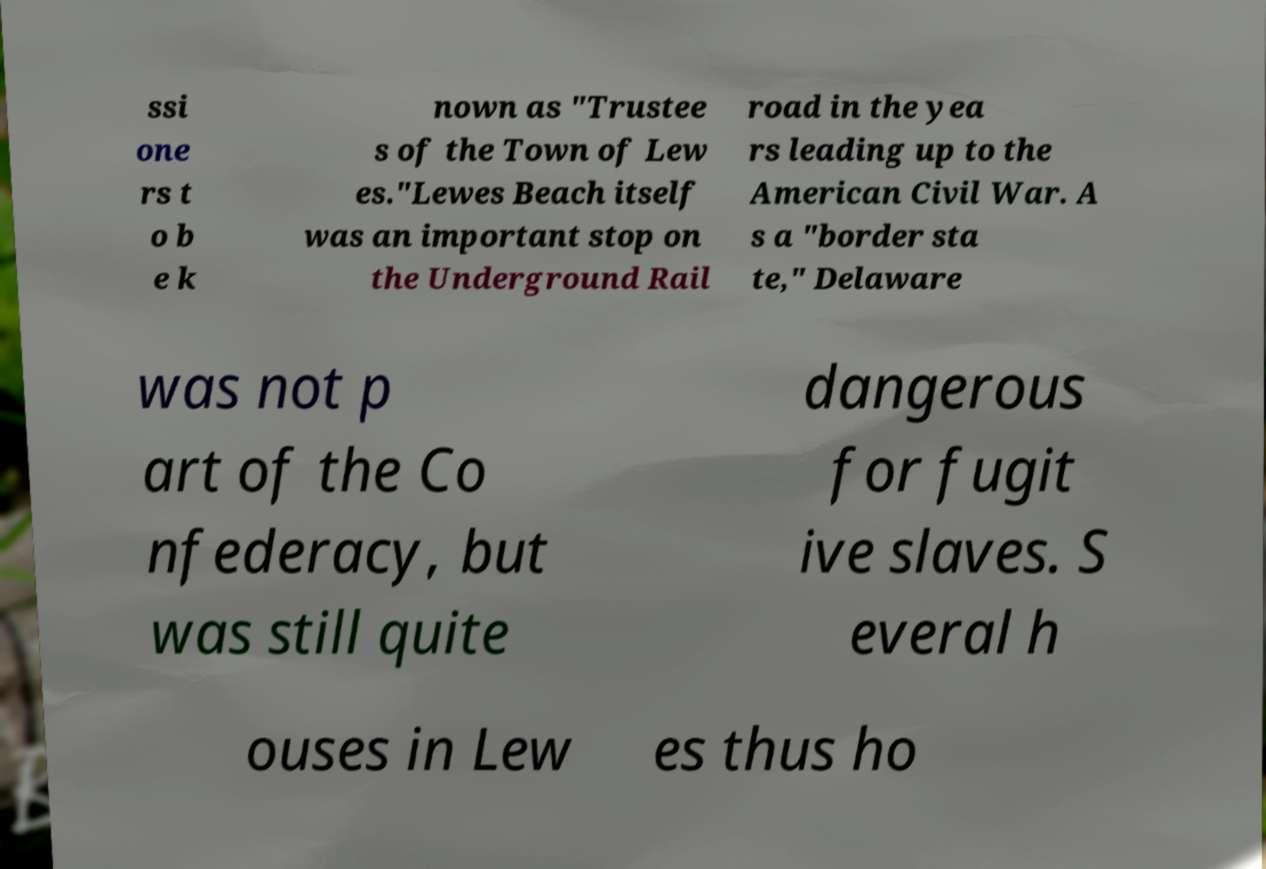There's text embedded in this image that I need extracted. Can you transcribe it verbatim? ssi one rs t o b e k nown as "Trustee s of the Town of Lew es."Lewes Beach itself was an important stop on the Underground Rail road in the yea rs leading up to the American Civil War. A s a "border sta te," Delaware was not p art of the Co nfederacy, but was still quite dangerous for fugit ive slaves. S everal h ouses in Lew es thus ho 